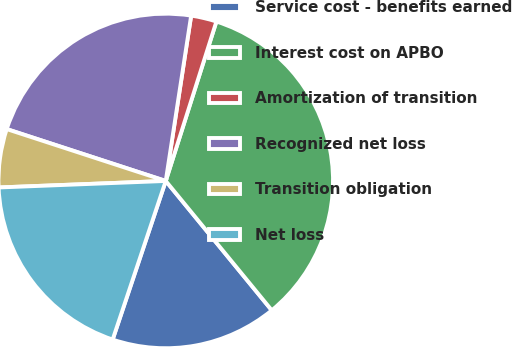Convert chart to OTSL. <chart><loc_0><loc_0><loc_500><loc_500><pie_chart><fcel>Service cost - benefits earned<fcel>Interest cost on APBO<fcel>Amortization of transition<fcel>Recognized net loss<fcel>Transition obligation<fcel>Net loss<nl><fcel>16.07%<fcel>34.18%<fcel>2.47%<fcel>22.41%<fcel>5.64%<fcel>19.24%<nl></chart> 